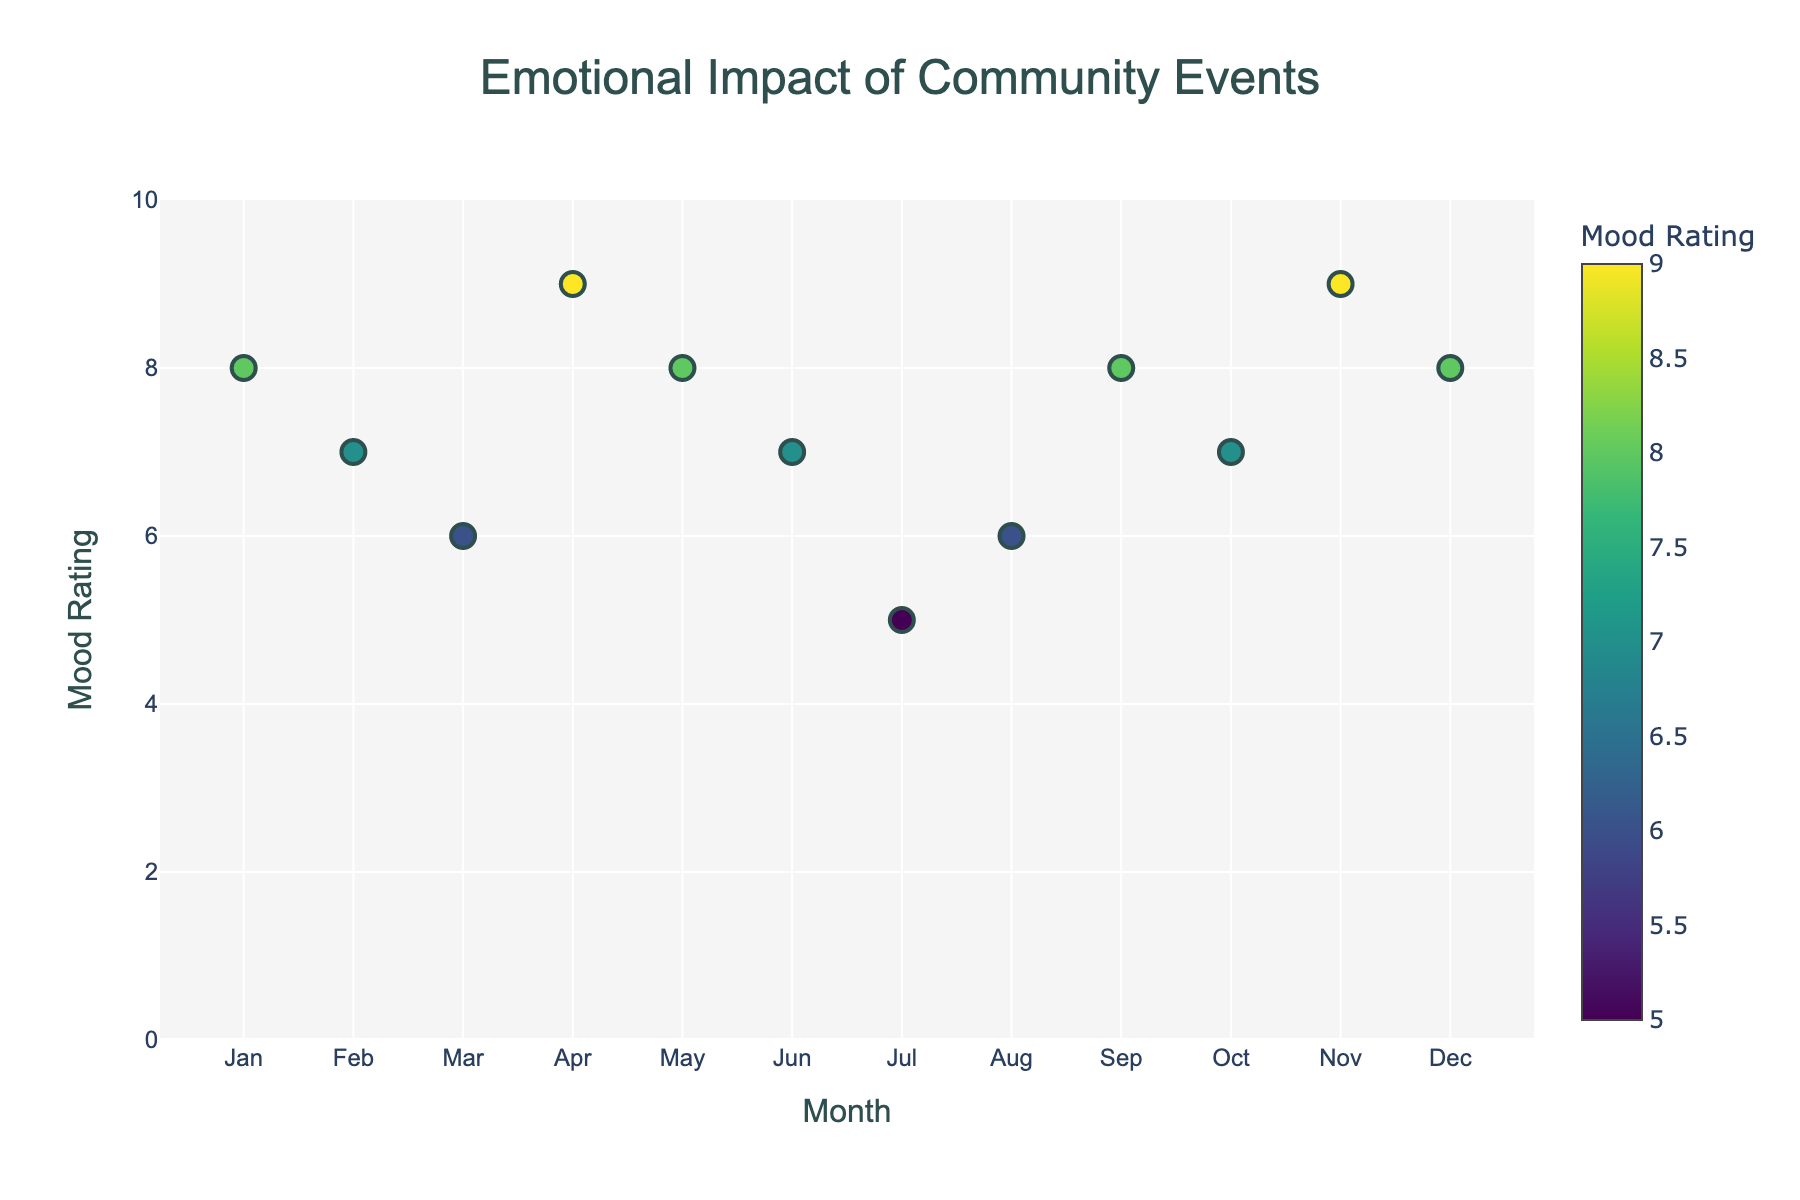What's the title of the plot? The title is located at the top center of the plot and reads: "Emotional Impact of Community Events".
Answer: Emotional Impact of Community Events What is the highest mood rating observed in the plot? The vertical axis represents Mood Rating. The highest value shown on the y-axis is 9.
Answer: 9 In which month does the lowest mood rating occur, and what is the rating? The x-axis represents the month, and the y-axis shows the Mood Rating. The lowest mood rating is 5, occurring in July (Fourth of July Fireworks).
Answer: July, 5 How many community events have a mood rating of 7? By counting the markers on the plot with a Mood Rating of 7, there are four such events: Valentine's Day Charity Bake Sale, Summer Solstice Picnic, Halloween Trick-or-Treat Safety Walk, and one more not named in the brief question.
Answer: 4 Compare the mood ratings of the Thanksgiving Food Bank Volunteer Day and the Fourth of July Fireworks. Which event has a higher rating and by how much? The plot shows Thanksgiving Food Bank Volunteer Day with a Mood Rating of 9 and Fourth of July Fireworks with a Mood Rating of 5. Hence, the Thanksgiving event has a higher rating by 4 points.
Answer: Thanksgiving Food Bank Volunteer Day, by 4 points What is the average mood rating of the events taking place in the first half of the year (January to June)? Calculate the average of the Mood Ratings for New Year's Block Party (8), Valentine's Day Charity Bake Sale (7), Spring Cleaning Community Drive (6), Easter Egg Hunt in the Park (9), Mother's Day Tea Party (8), Summer Solstice Picnic (7): (8+7+6+9+8+7)/6 = 7.5
Answer: 7.5 What months see events with mood ratings above 8? By checking the given Manhattan plot, the events with Mood Ratings above 8 occur in April (Easter Egg Hunt in the Park) and November (Thanksgiving Food Bank Volunteer Day).
Answer: April, November How does the mood rating for Holiday Light Display Competition (December) compare to that of Back-to-School Supply Donation (August)? The plot shows the Holiday Light Display Competition with a Mood Rating of 8 and Back-to-School Supply Donation with a Mood Rating of 6, indicating the mood rating for December is higher by 2 points.
Answer: December is higher by 2 points Which event has the highest mood rating, and what is its rating? The highest point on the y-axis of the plot represents the Mood Rating, and the event corresponding to the highest point (rating 9) is the Easter Egg Hunt in the Park and Thanksgiving Food Bank Volunteer Day.
Answer: Easter Egg Hunt in the Park and Thanksgiving Food Bank Volunteer Day, 9 